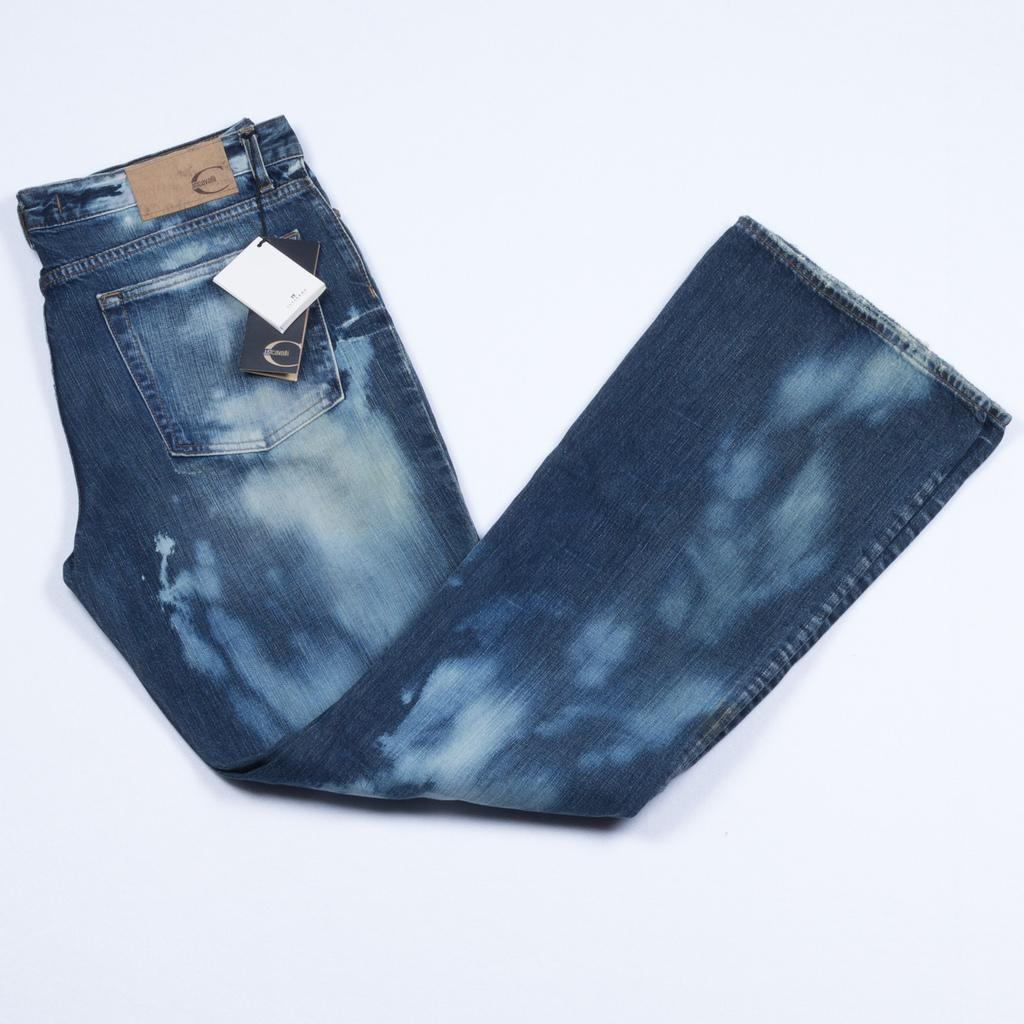What type of clothing item is visible in the image? There is a pair of jeans in the image. What additional information can be gathered about the jeans? The jeans contain tags. Where are the jeans located in the image? The jeans are present on a surface. How many friends are visible in the image? There are no friends present in the image; it only features a pair of jeans. What type of button is on the jeans in the image? There is no button mentioned in the provided facts, so we cannot determine if there is a button on the jeans or not. 